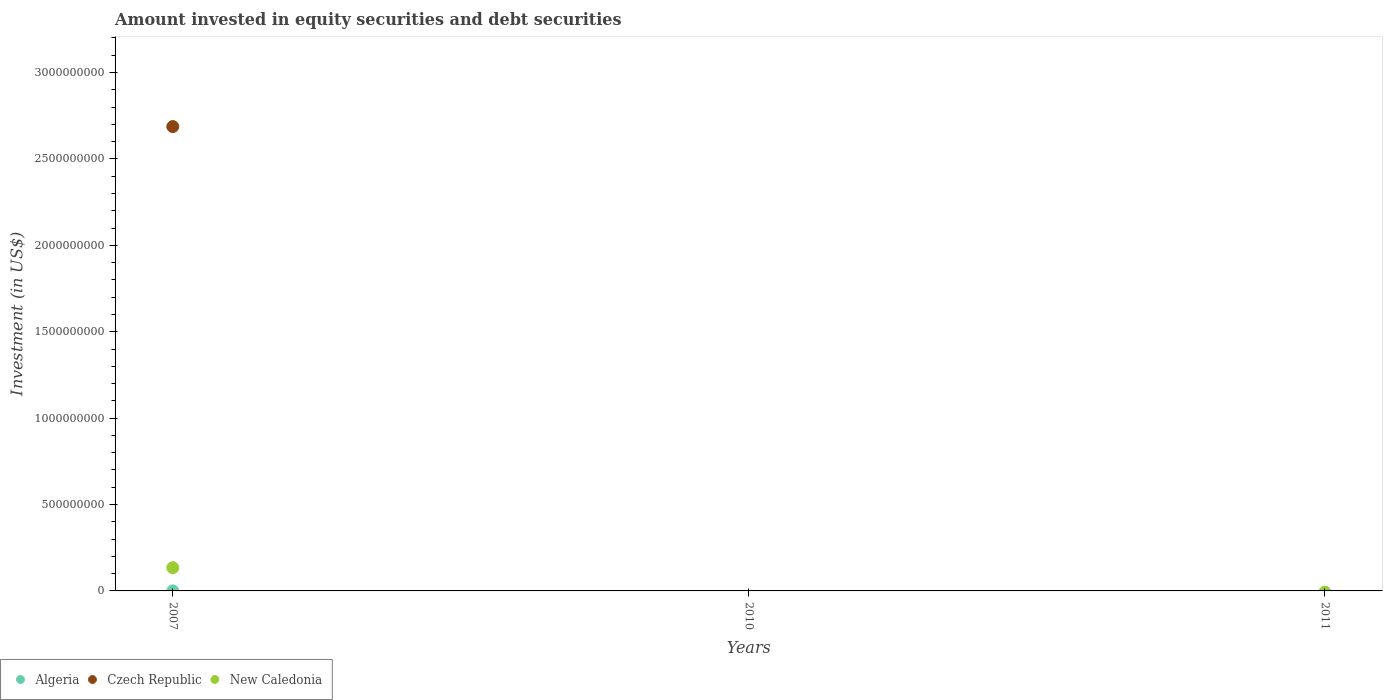How many different coloured dotlines are there?
Keep it short and to the point. 3. What is the amount invested in equity securities and debt securities in Algeria in 2007?
Ensure brevity in your answer.  1.66e+05. Across all years, what is the maximum amount invested in equity securities and debt securities in Algeria?
Give a very brief answer. 1.66e+05. Across all years, what is the minimum amount invested in equity securities and debt securities in Czech Republic?
Give a very brief answer. 0. In which year was the amount invested in equity securities and debt securities in New Caledonia maximum?
Keep it short and to the point. 2007. What is the total amount invested in equity securities and debt securities in New Caledonia in the graph?
Offer a terse response. 1.34e+08. What is the difference between the amount invested in equity securities and debt securities in New Caledonia in 2011 and the amount invested in equity securities and debt securities in Czech Republic in 2007?
Offer a very short reply. -2.69e+09. What is the average amount invested in equity securities and debt securities in New Caledonia per year?
Give a very brief answer. 4.48e+07. In the year 2007, what is the difference between the amount invested in equity securities and debt securities in New Caledonia and amount invested in equity securities and debt securities in Czech Republic?
Ensure brevity in your answer.  -2.55e+09. In how many years, is the amount invested in equity securities and debt securities in Czech Republic greater than 1800000000 US$?
Provide a short and direct response. 1. What is the difference between the highest and the lowest amount invested in equity securities and debt securities in Algeria?
Give a very brief answer. 1.66e+05. Does the amount invested in equity securities and debt securities in Algeria monotonically increase over the years?
Your response must be concise. No. Is the amount invested in equity securities and debt securities in Algeria strictly greater than the amount invested in equity securities and debt securities in New Caledonia over the years?
Your answer should be very brief. No. How many dotlines are there?
Provide a short and direct response. 3. How many years are there in the graph?
Your answer should be compact. 3. What is the difference between two consecutive major ticks on the Y-axis?
Make the answer very short. 5.00e+08. How are the legend labels stacked?
Keep it short and to the point. Horizontal. What is the title of the graph?
Ensure brevity in your answer.  Amount invested in equity securities and debt securities. What is the label or title of the Y-axis?
Your answer should be compact. Investment (in US$). What is the Investment (in US$) of Algeria in 2007?
Provide a succinct answer. 1.66e+05. What is the Investment (in US$) of Czech Republic in 2007?
Offer a very short reply. 2.69e+09. What is the Investment (in US$) of New Caledonia in 2007?
Your answer should be very brief. 1.34e+08. What is the Investment (in US$) in Algeria in 2010?
Give a very brief answer. 0. What is the Investment (in US$) of Czech Republic in 2010?
Offer a very short reply. 0. What is the Investment (in US$) of Czech Republic in 2011?
Make the answer very short. 0. Across all years, what is the maximum Investment (in US$) in Algeria?
Your response must be concise. 1.66e+05. Across all years, what is the maximum Investment (in US$) of Czech Republic?
Make the answer very short. 2.69e+09. Across all years, what is the maximum Investment (in US$) in New Caledonia?
Give a very brief answer. 1.34e+08. What is the total Investment (in US$) in Algeria in the graph?
Make the answer very short. 1.66e+05. What is the total Investment (in US$) of Czech Republic in the graph?
Offer a terse response. 2.69e+09. What is the total Investment (in US$) in New Caledonia in the graph?
Provide a short and direct response. 1.34e+08. What is the average Investment (in US$) in Algeria per year?
Make the answer very short. 5.54e+04. What is the average Investment (in US$) in Czech Republic per year?
Your response must be concise. 8.96e+08. What is the average Investment (in US$) in New Caledonia per year?
Give a very brief answer. 4.48e+07. In the year 2007, what is the difference between the Investment (in US$) in Algeria and Investment (in US$) in Czech Republic?
Your response must be concise. -2.69e+09. In the year 2007, what is the difference between the Investment (in US$) of Algeria and Investment (in US$) of New Caledonia?
Offer a terse response. -1.34e+08. In the year 2007, what is the difference between the Investment (in US$) of Czech Republic and Investment (in US$) of New Caledonia?
Your answer should be very brief. 2.55e+09. What is the difference between the highest and the lowest Investment (in US$) in Algeria?
Ensure brevity in your answer.  1.66e+05. What is the difference between the highest and the lowest Investment (in US$) of Czech Republic?
Provide a succinct answer. 2.69e+09. What is the difference between the highest and the lowest Investment (in US$) of New Caledonia?
Your answer should be compact. 1.34e+08. 